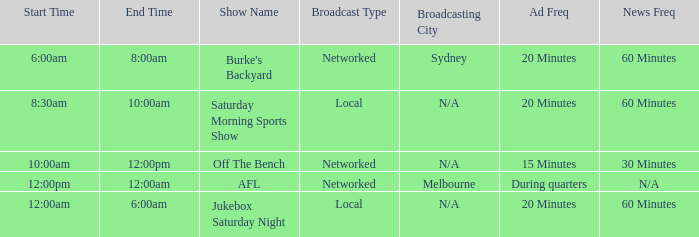What is the frequency of ads for the program "show off the bench"? 15 Minutes. 